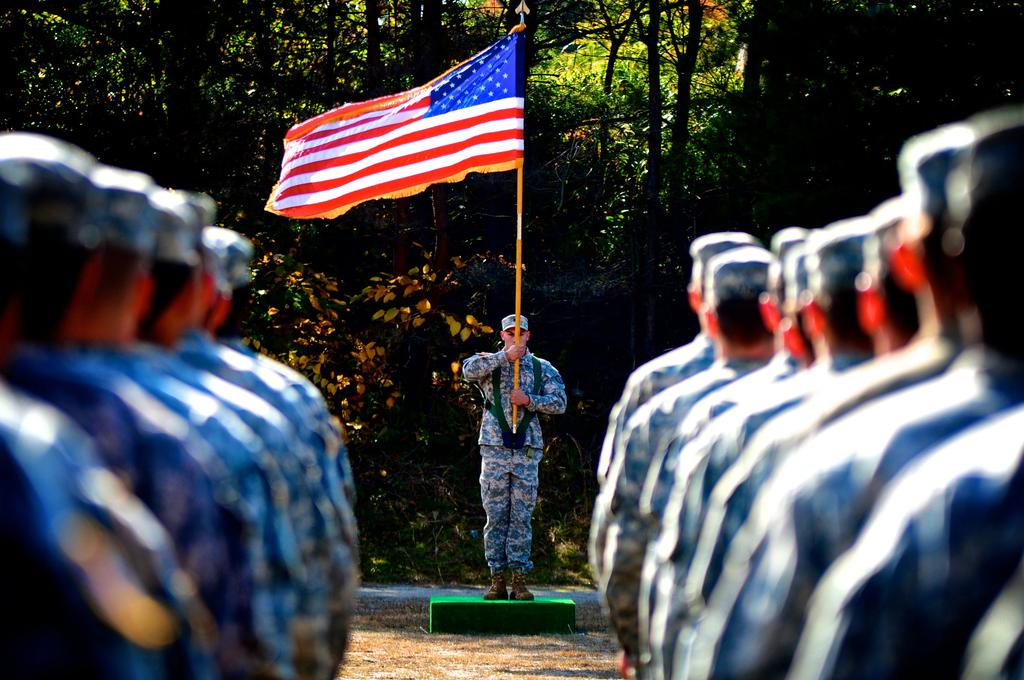What are the people in the image doing? The people in the image are standing in a line. Is there anyone with a specific role or item in the image? Yes, there is a person standing in front of the line and holding a flag. What can be seen in the background of the image? Trees are visible in the background of the image. What type of machine can be seen operating in the background of the image? There is no machine visible in the image; it only shows people standing in a line and trees in the background. 